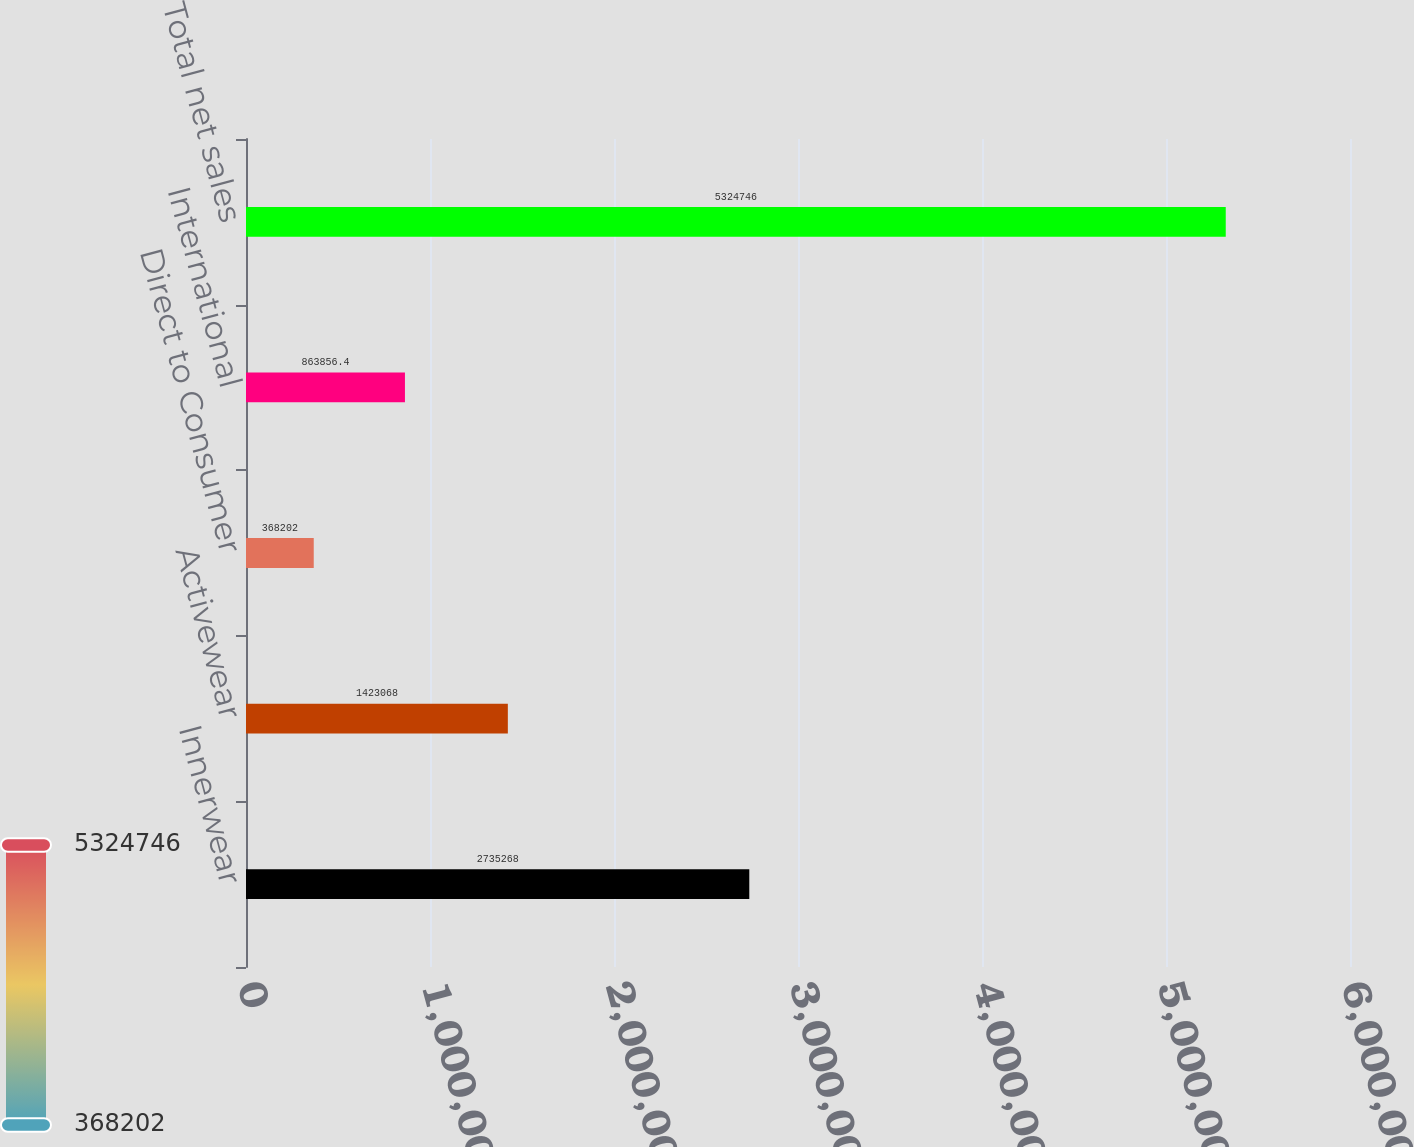Convert chart to OTSL. <chart><loc_0><loc_0><loc_500><loc_500><bar_chart><fcel>Innerwear<fcel>Activewear<fcel>Direct to Consumer<fcel>International<fcel>Total net sales<nl><fcel>2.73527e+06<fcel>1.42307e+06<fcel>368202<fcel>863856<fcel>5.32475e+06<nl></chart> 